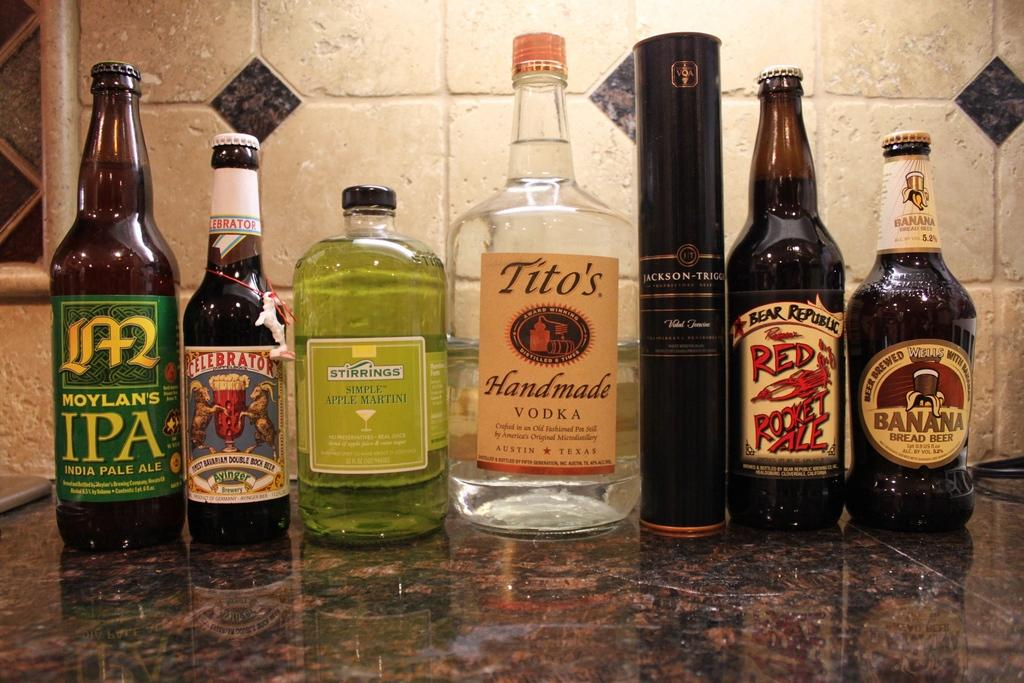<image>
Relay a brief, clear account of the picture shown. a counter of lined up bottles with one of them labeled 'tito's handmade vodka' 